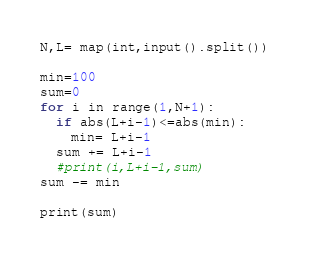Convert code to text. <code><loc_0><loc_0><loc_500><loc_500><_Python_>N,L= map(int,input().split())

min=100
sum=0
for i in range(1,N+1):
  if abs(L+i-1)<=abs(min):
    min= L+i-1
  sum += L+i-1 
  #print(i,L+i-1,sum)
sum -= min

print(sum)
  </code> 